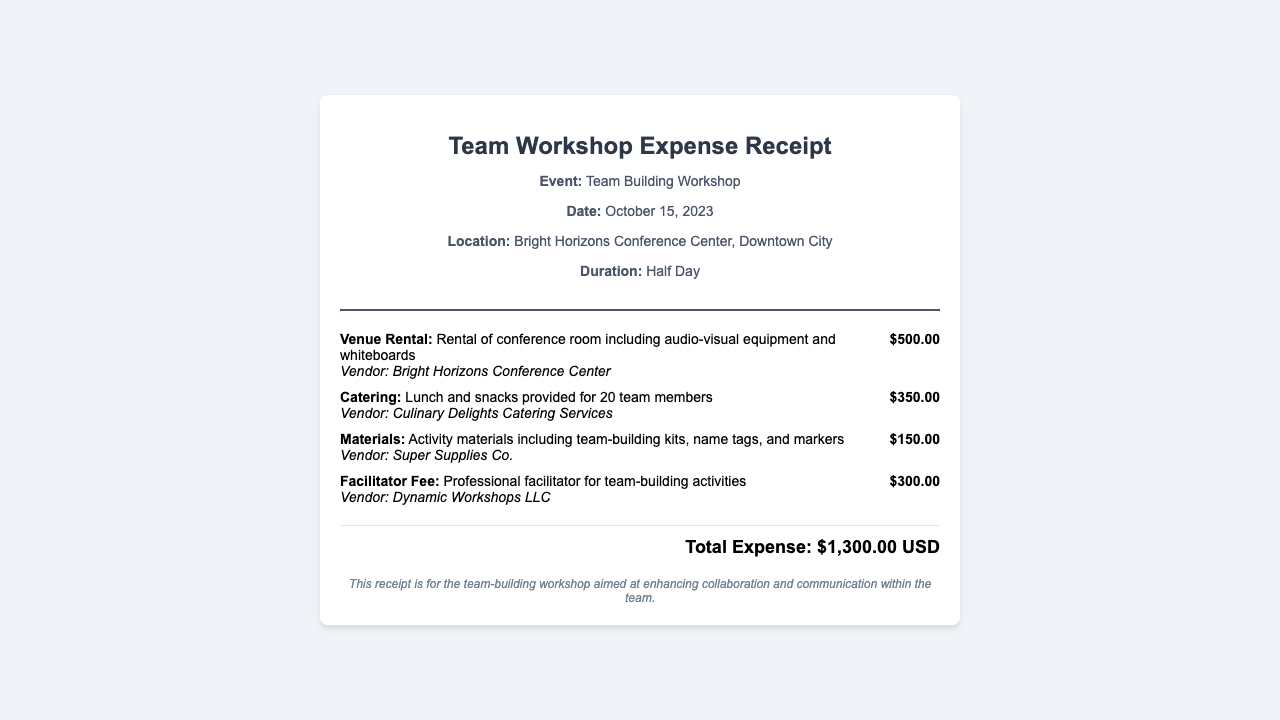What is the total expense? The total expense is the total amount incurred for the workshop, stated at the end of the document.
Answer: $1,300.00 USD What is the date of the workshop? The document specifies the date of the team-building workshop in the workshop details section.
Answer: October 15, 2023 Who provided the catering services? The vendor for the catering services is mentioned alongside the description of the catering expense.
Answer: Culinary Delights Catering Services How many team members were catered for? The catering description indicates the number of team members for whom meals were provided.
Answer: 20 What was the venue rental cost? The document states the cost specifically associated with the venue rental expense.
Answer: $500.00 Which company was hired as the facilitator? The vendor for the facilitator fee is indicated in the expense description for the facilitator.
Answer: Dynamic Workshops LLC What does the total expense include? The total expense includes several specific costs mentioned throughout the document, summarizing the overall financial aspect of the workshop.
Answer: Venue Rental, Catering, Materials, Facilitator Fee What was included in the materials cost? The materials expense description outlines what items were purchased for the workshop activities.
Answer: Team-building kits, name tags, and markers What type of event is this receipt for? The title of the receipt specifically identifies the type of event that this expense relates to.
Answer: Team Building Workshop 